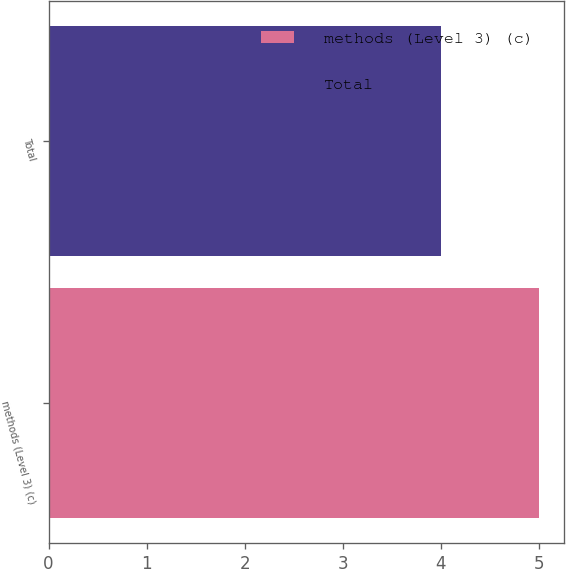Convert chart to OTSL. <chart><loc_0><loc_0><loc_500><loc_500><bar_chart><fcel>methods (Level 3) (c)<fcel>Total<nl><fcel>5<fcel>4<nl></chart> 